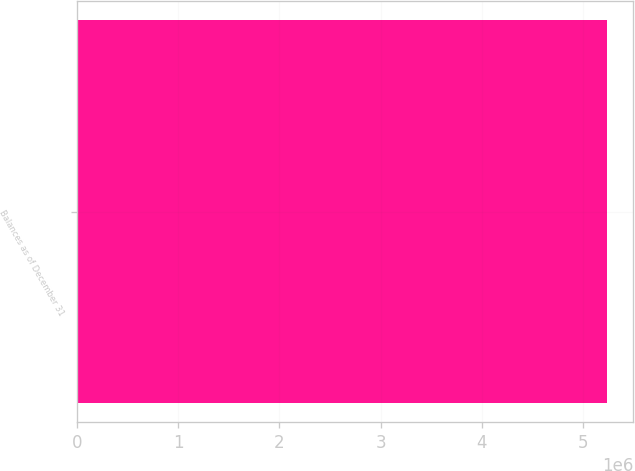Convert chart to OTSL. <chart><loc_0><loc_0><loc_500><loc_500><bar_chart><fcel>Balances as of December 31<nl><fcel>5.23876e+06<nl></chart> 